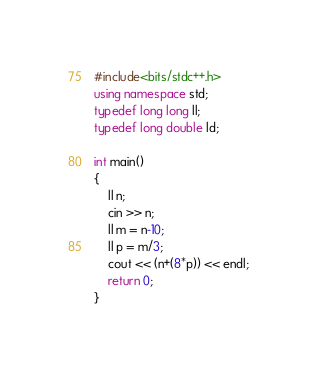<code> <loc_0><loc_0><loc_500><loc_500><_C++_>#include<bits/stdc++.h>
using namespace std;
typedef long long ll;
typedef long double ld;

int main()
{
    ll n;
    cin >> n;
    ll m = n-10;
    ll p = m/3;
    cout << (n+(8*p)) << endl;
    return 0;
}
</code> 